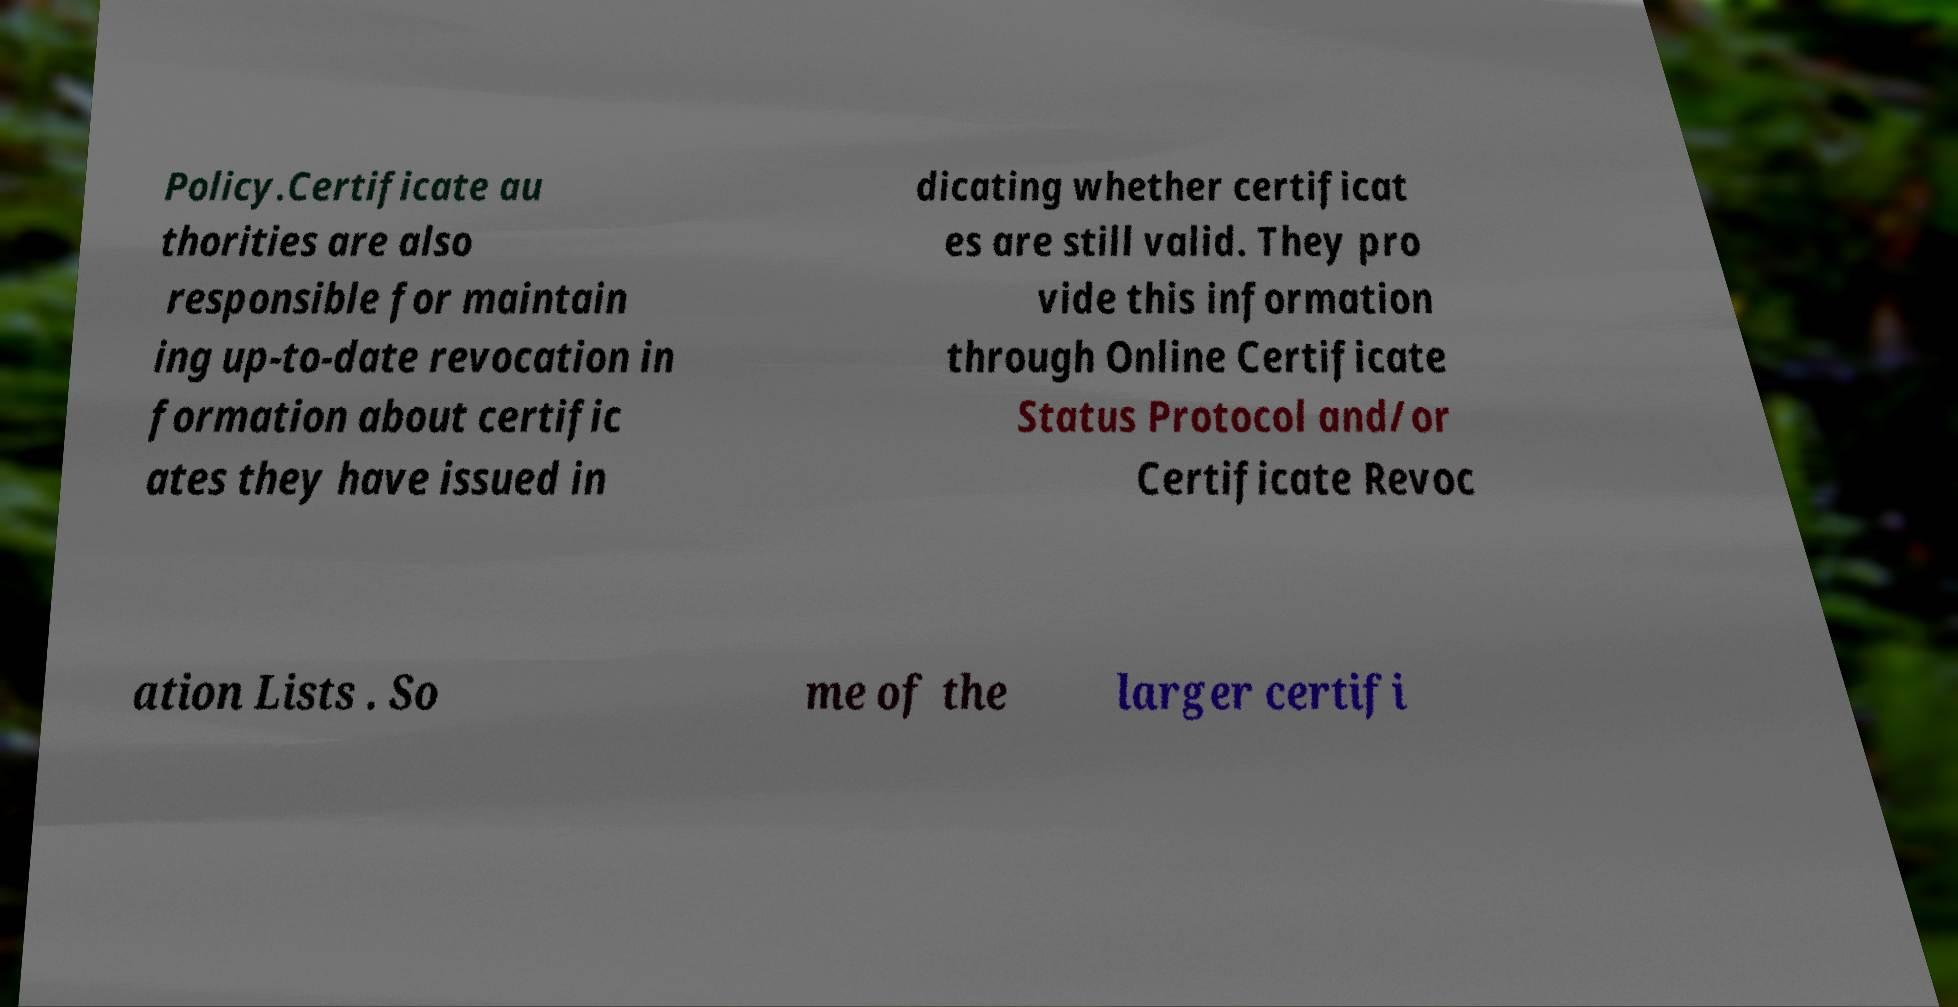Please read and relay the text visible in this image. What does it say? Policy.Certificate au thorities are also responsible for maintain ing up-to-date revocation in formation about certific ates they have issued in dicating whether certificat es are still valid. They pro vide this information through Online Certificate Status Protocol and/or Certificate Revoc ation Lists . So me of the larger certifi 